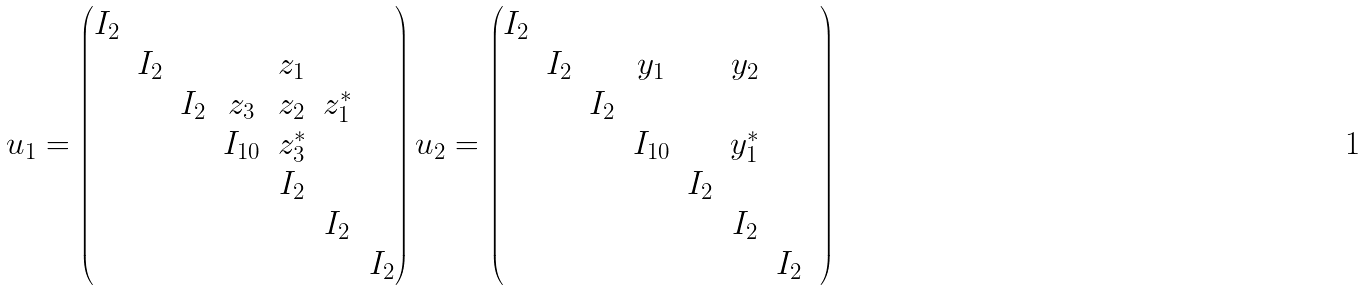Convert formula to latex. <formula><loc_0><loc_0><loc_500><loc_500>u _ { 1 } = \begin{pmatrix} I _ { 2 } & & & & & & \\ & I _ { 2 } & & & z _ { 1 } & & \\ & & I _ { 2 } & z _ { 3 } & z _ { 2 } & z _ { 1 } ^ { * } & \\ & & & I _ { 1 0 } & z _ { 3 } ^ { * } & & \\ & & & & I _ { 2 } & & \\ & & & & & I _ { 2 } & \\ & & & & & & I _ { 2 } \end{pmatrix} u _ { 2 } = \begin{pmatrix} I _ { 2 } & & & & & & \\ & I _ { 2 } & & y _ { 1 } & & y _ { 2 } & & \\ & & I _ { 2 } & & & & \\ & & & I _ { 1 0 } & & y _ { 1 } ^ { * } & \\ & & & & I _ { 2 } & & \\ & & & & & I _ { 2 } & \\ & & & & & & I _ { 2 } \end{pmatrix}</formula> 